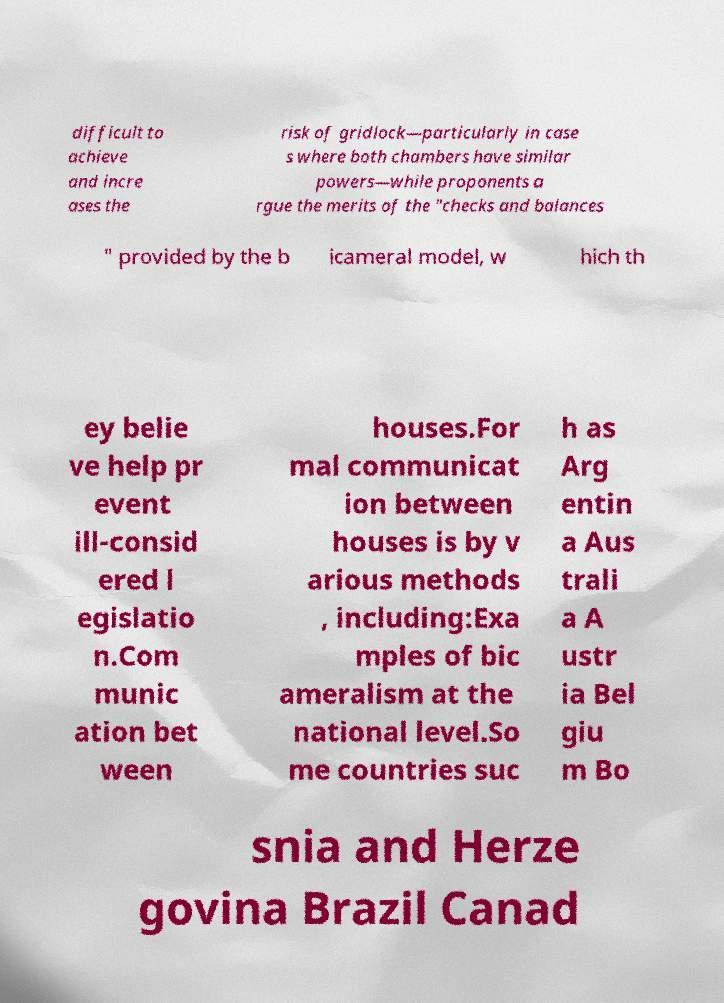For documentation purposes, I need the text within this image transcribed. Could you provide that? difficult to achieve and incre ases the risk of gridlock—particularly in case s where both chambers have similar powers—while proponents a rgue the merits of the "checks and balances " provided by the b icameral model, w hich th ey belie ve help pr event ill-consid ered l egislatio n.Com munic ation bet ween houses.For mal communicat ion between houses is by v arious methods , including:Exa mples of bic ameralism at the national level.So me countries suc h as Arg entin a Aus trali a A ustr ia Bel giu m Bo snia and Herze govina Brazil Canad 